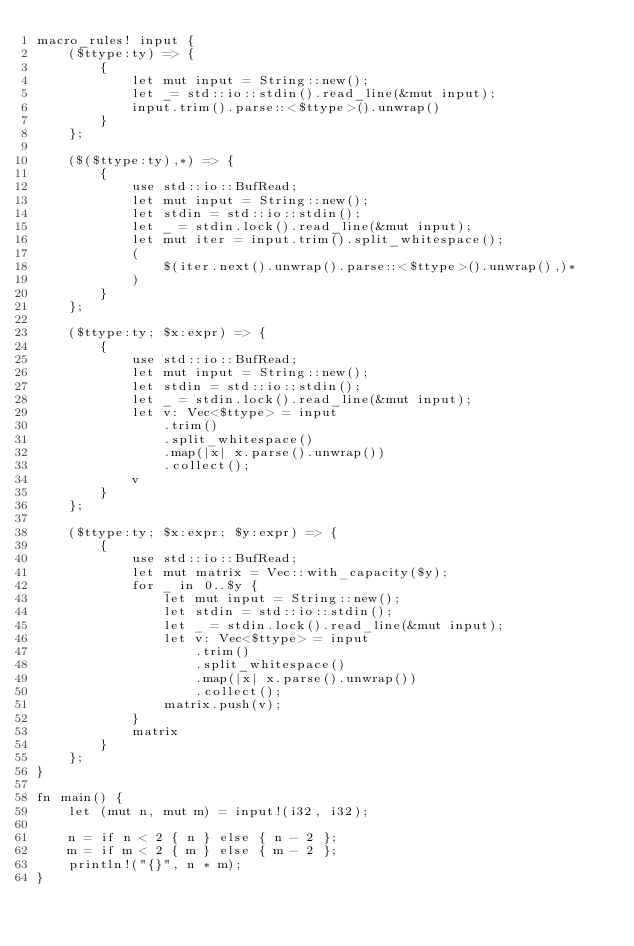<code> <loc_0><loc_0><loc_500><loc_500><_Rust_>macro_rules! input {
    ($ttype:ty) => {
        {
            let mut input = String::new();
            let _= std::io::stdin().read_line(&mut input);
            input.trim().parse::<$ttype>().unwrap()
        }
    };

    ($($ttype:ty),*) => {
        {
            use std::io::BufRead;
            let mut input = String::new();
            let stdin = std::io::stdin();
            let _ = stdin.lock().read_line(&mut input);
            let mut iter = input.trim().split_whitespace();
            (
                $(iter.next().unwrap().parse::<$ttype>().unwrap(),)*
            )
        }
    };

    ($ttype:ty; $x:expr) => {
        {
            use std::io::BufRead;
            let mut input = String::new();
            let stdin = std::io::stdin();
            let _ = stdin.lock().read_line(&mut input);
            let v: Vec<$ttype> = input
                .trim()
                .split_whitespace()
                .map(|x| x.parse().unwrap())
                .collect();
            v
        }
    };

    ($ttype:ty; $x:expr; $y:expr) => {
        {
            use std::io::BufRead;
            let mut matrix = Vec::with_capacity($y);
            for _ in 0..$y {
                let mut input = String::new();
                let stdin = std::io::stdin();
                let _ = stdin.lock().read_line(&mut input);
                let v: Vec<$ttype> = input
                    .trim()
                    .split_whitespace()
                    .map(|x| x.parse().unwrap())
                    .collect();
                matrix.push(v);
            }
            matrix
        }
    };
}

fn main() {
    let (mut n, mut m) = input!(i32, i32);

    n = if n < 2 { n } else { n - 2 };
    m = if m < 2 { m } else { m - 2 };
    println!("{}", n * m);
}</code> 